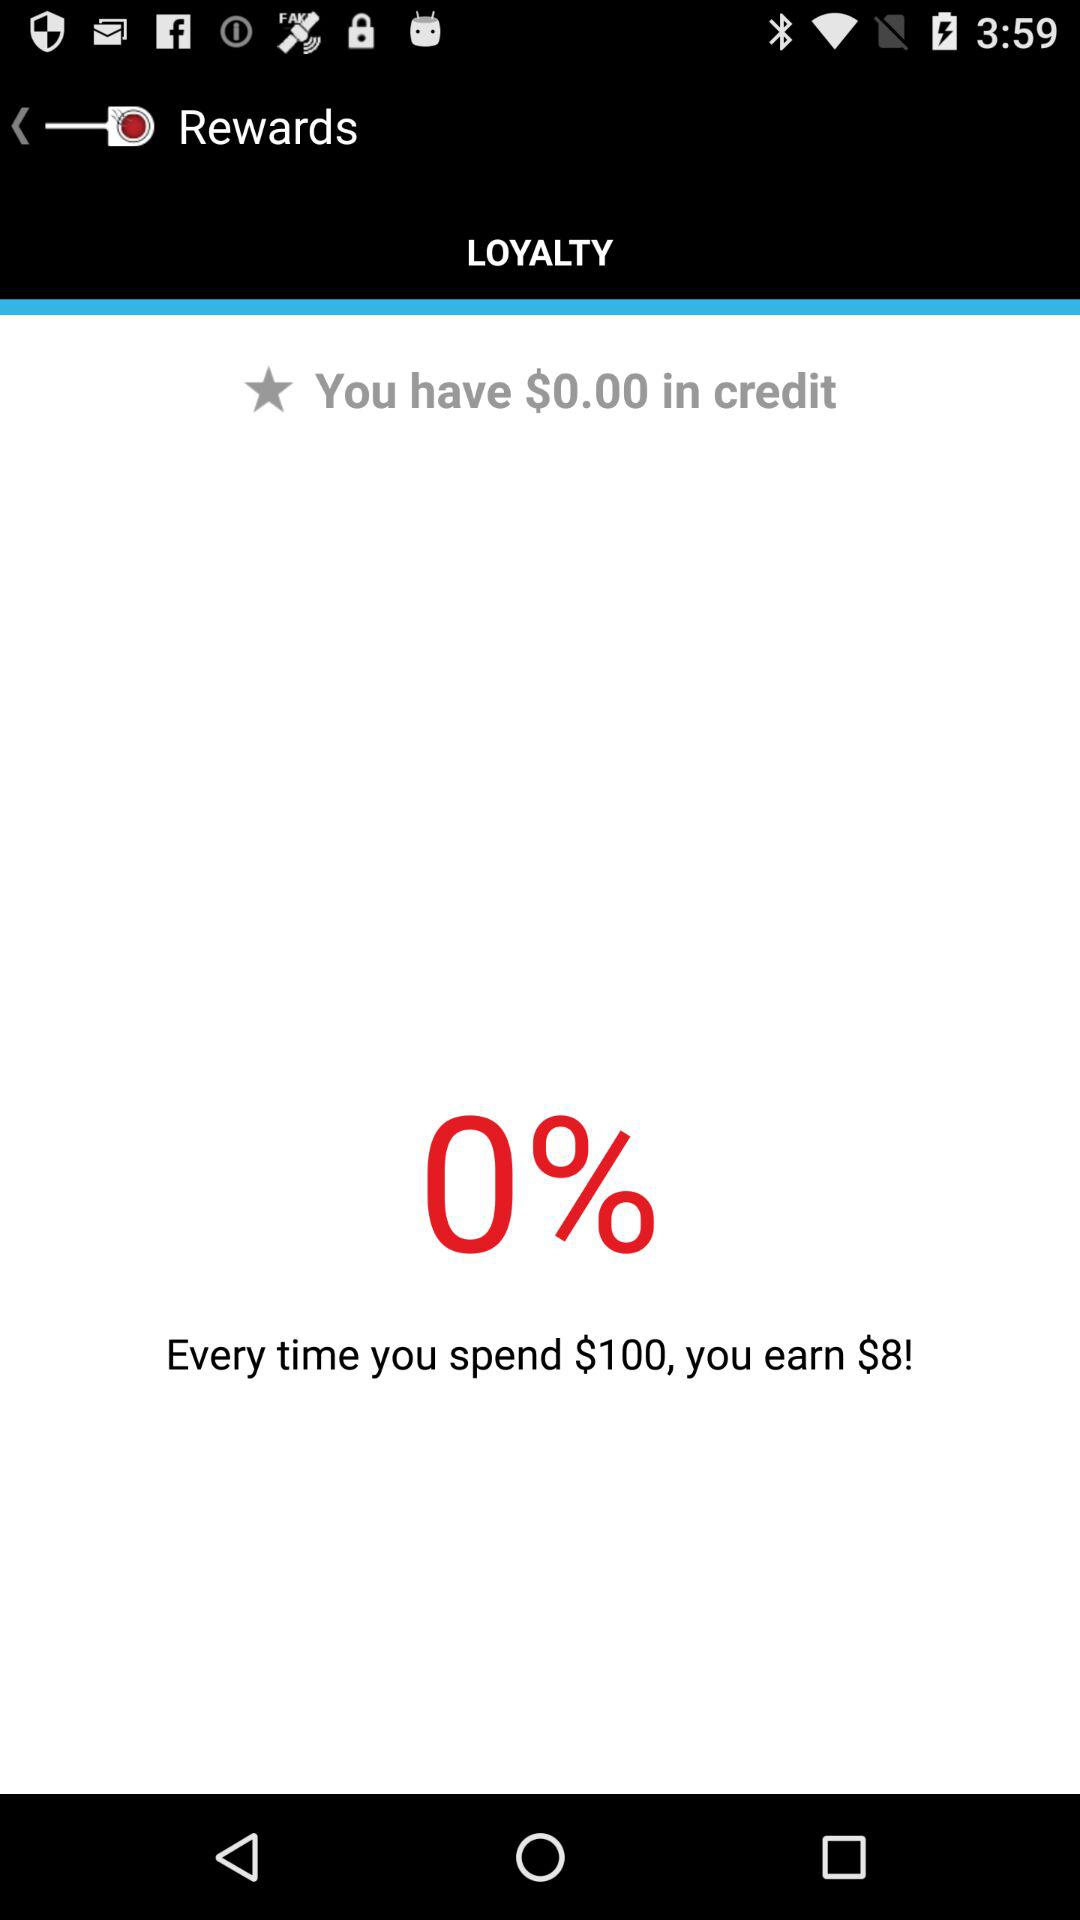What is the current balance of your loyalty account?
Answer the question using a single word or phrase. $0.00 